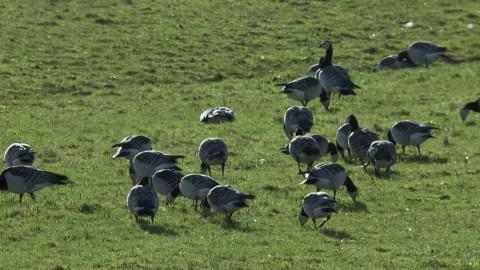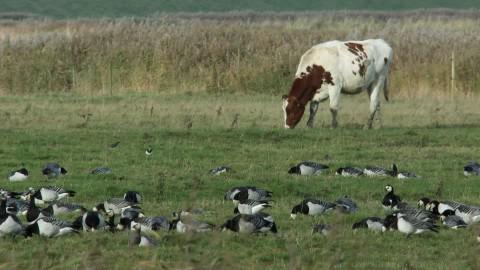The first image is the image on the left, the second image is the image on the right. Examine the images to the left and right. Is the description "One of the images shows at least one cow standing in a field behind a flock of geese." accurate? Answer yes or no. Yes. The first image is the image on the left, the second image is the image on the right. For the images shown, is this caption "An image includes at least one cow standing behind a flock of birds in a field." true? Answer yes or no. Yes. 